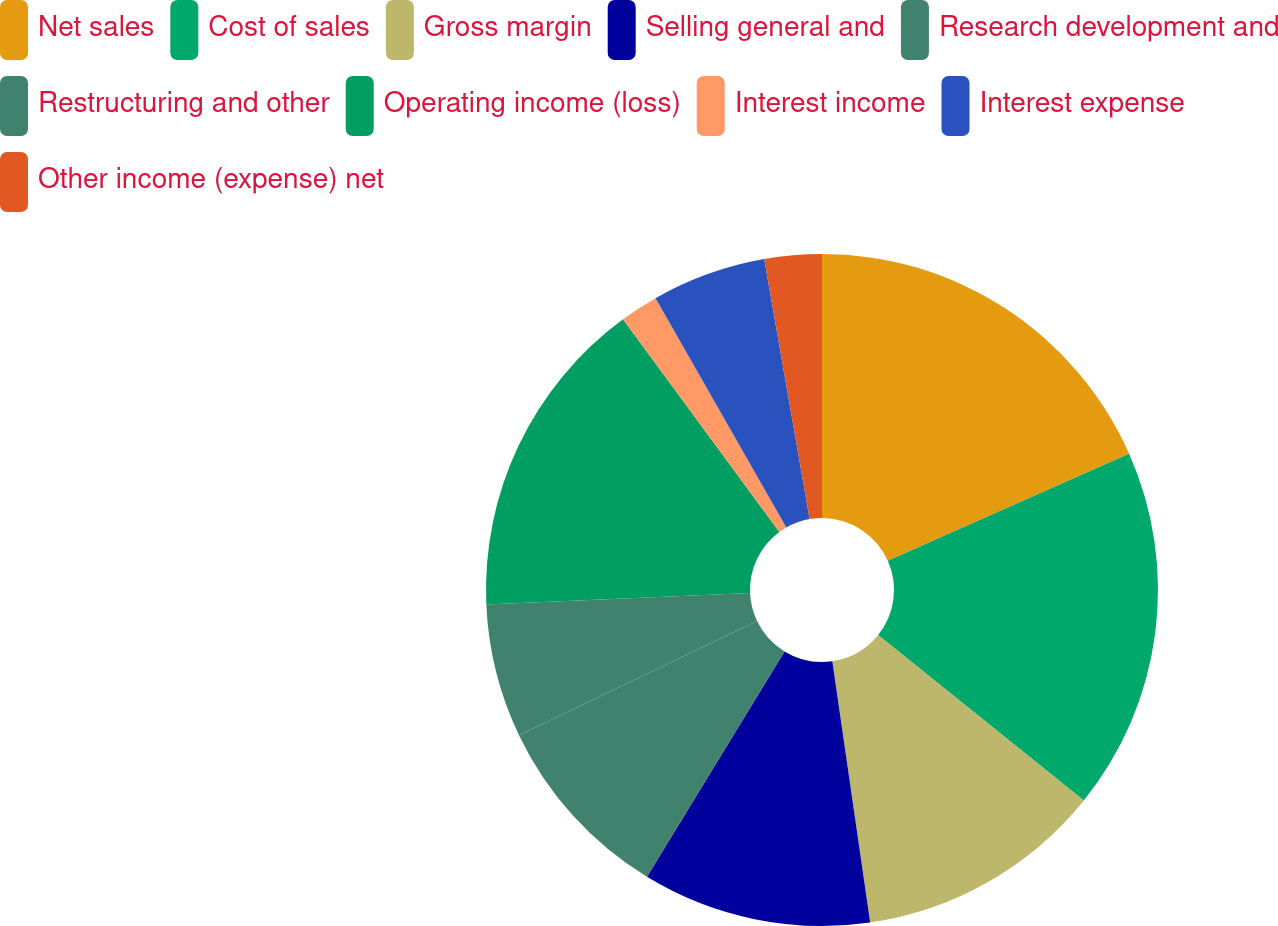Convert chart to OTSL. <chart><loc_0><loc_0><loc_500><loc_500><pie_chart><fcel>Net sales<fcel>Cost of sales<fcel>Gross margin<fcel>Selling general and<fcel>Research development and<fcel>Restructuring and other<fcel>Operating income (loss)<fcel>Interest income<fcel>Interest expense<fcel>Other income (expense) net<nl><fcel>18.35%<fcel>17.43%<fcel>11.93%<fcel>11.01%<fcel>9.17%<fcel>6.42%<fcel>15.6%<fcel>1.84%<fcel>5.5%<fcel>2.75%<nl></chart> 